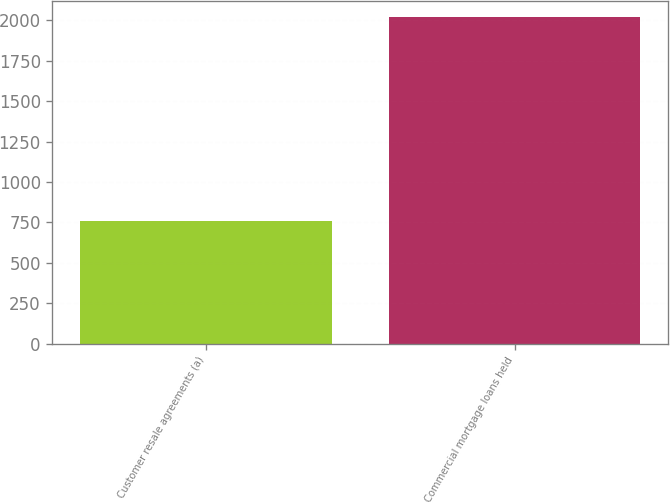<chart> <loc_0><loc_0><loc_500><loc_500><bar_chart><fcel>Customer resale agreements (a)<fcel>Commercial mortgage loans held<nl><fcel>761<fcel>2020<nl></chart> 